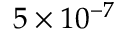Convert formula to latex. <formula><loc_0><loc_0><loc_500><loc_500>5 \times 1 0 ^ { - 7 }</formula> 